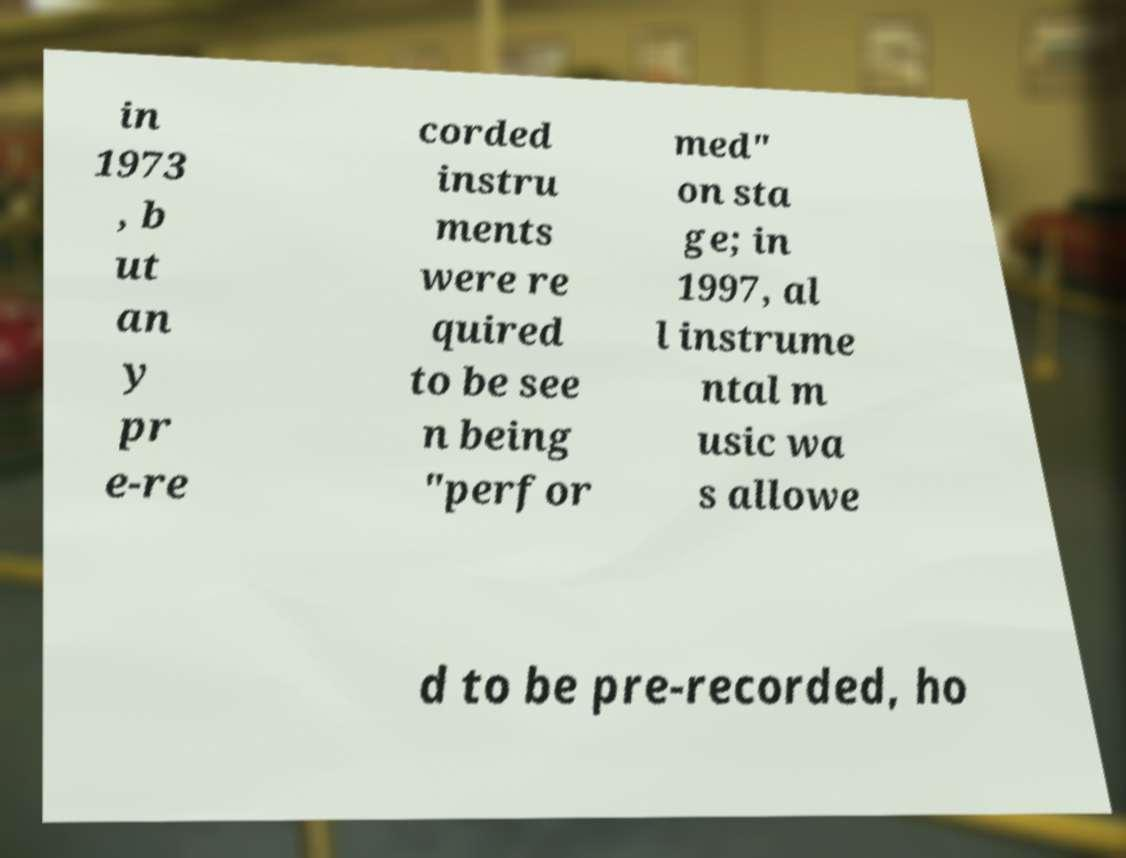What messages or text are displayed in this image? I need them in a readable, typed format. in 1973 , b ut an y pr e-re corded instru ments were re quired to be see n being "perfor med" on sta ge; in 1997, al l instrume ntal m usic wa s allowe d to be pre-recorded, ho 